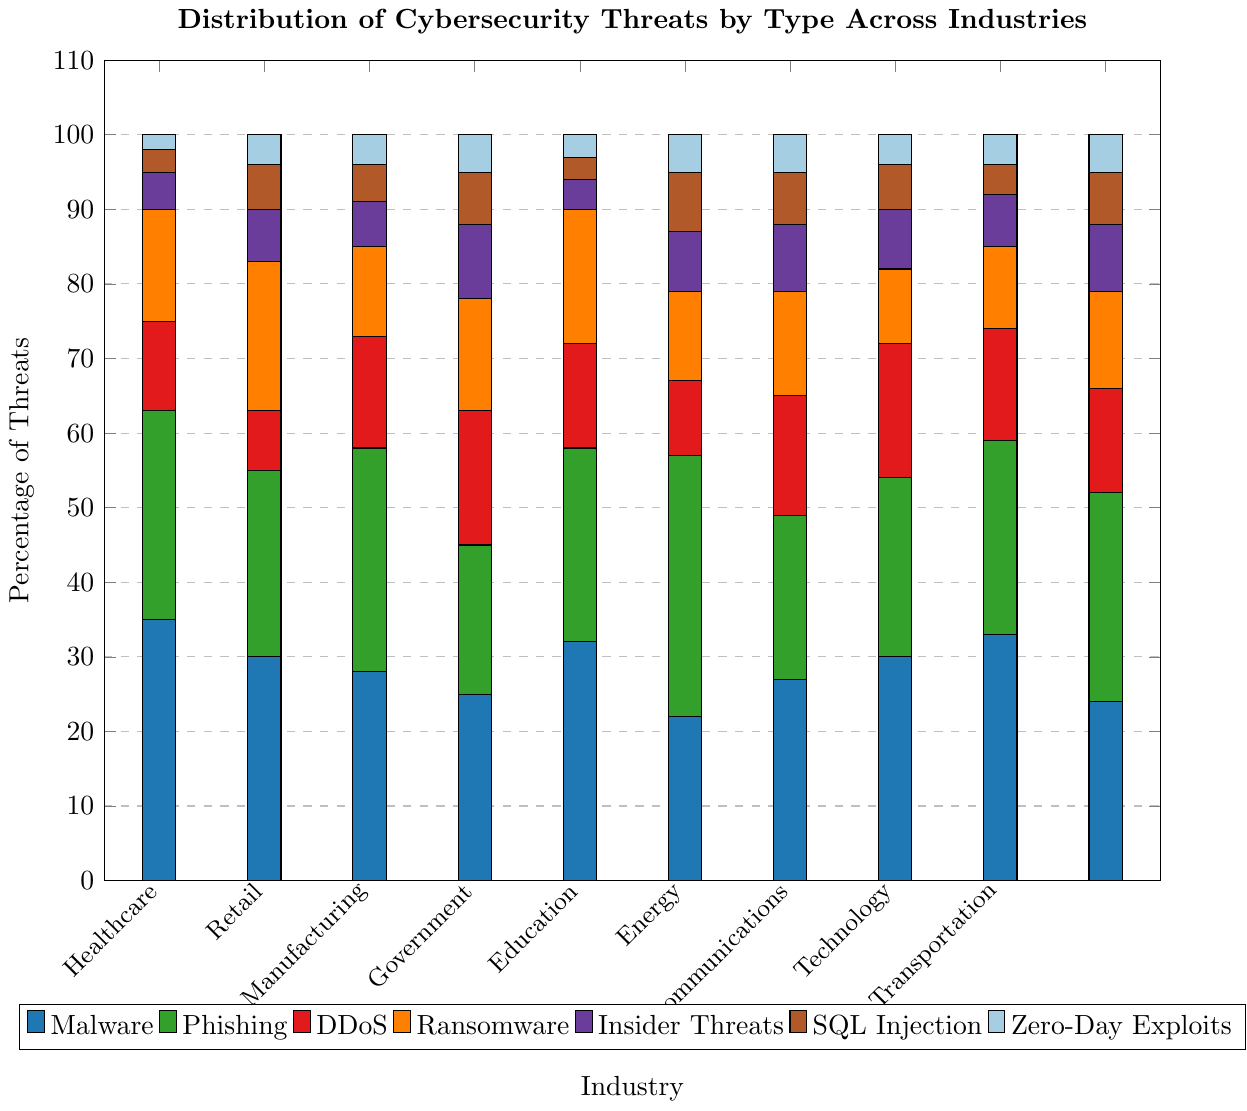What industry has the highest percentage of Phishing threats? Look at the teal-colored sections of the bars, which represent Phishing threats, and identify the industry with the tallest bar segment in that color.
Answer: Education How does the proportion of Malware threats in Financial Services compare to those in Retail? Compare the height of the blue segments for Financial Services (35%) and Retail (28%). Financial Services has a higher proportion by 7%.
Answer: Financial Services has 7% more Which threat type is most prevalent in the Healthcare industry? Identify the tallest segment within the Healthcare industry bar. The blue segment for Malware is higher than the others at 30%.
Answer: Malware What is the combined percentage of DDoS and Ransomware threats in the Manufacturing industry? Sum the heights of the red (DDoS) and orange (Ransomware) segments in the Manufacturing bar: 18% + 15% = 33%.
Answer: 33% In which industry is SQL Injection least prevalent? Identify the industry with the shortest brown segment, which represents SQL Injection. Both Financial Services and Government have the lowest values at 3%.
Answer: Financial Services and Government Compare the percentage of Zero-Day Exploits in the Energy and Technology industries. Which has more and by how much? Compare the heights of the light blue segments for both industries. Energy has a 5% bar, and Technology has a 4% bar, so Energy has 1% more.
Answer: Energy has 1% more Which industry has the most balanced distribution of all threat types, excluding the most extreme values? Look for the industry with relatively equal segment heights across all colors. The Telecommunications bar has segments of 30%, 24%, 18%, 10%, 8%, 6%, and 4%, suggesting a more balanced distribution.
Answer: Telecommunications What is the least common threat type for the Government industry, and what is its percentage? Identify the smallest segment in the Government bar. Both SQL Injection and Zero-Day Exploits are the smallest at 3%.
Answer: SQL Injection and Zero-Day Exploits, both 3% How many industries have Ransomware threats exceeding 15%? Identify the bars with an orange segment higher than 15%. Healthcare and Government have 20% and 18%, respectively, making a total of 2 industries.
Answer: 2 industries If you were to focus on the Telecommunication industry, which three threat types should you prioritize based on their frequencies? Look for the three tallest segments within the Telecommunication bar. They are Malware (30%), Phishing (24%), and DDoS (18%).
Answer: Malware, Phishing, and DDoS 